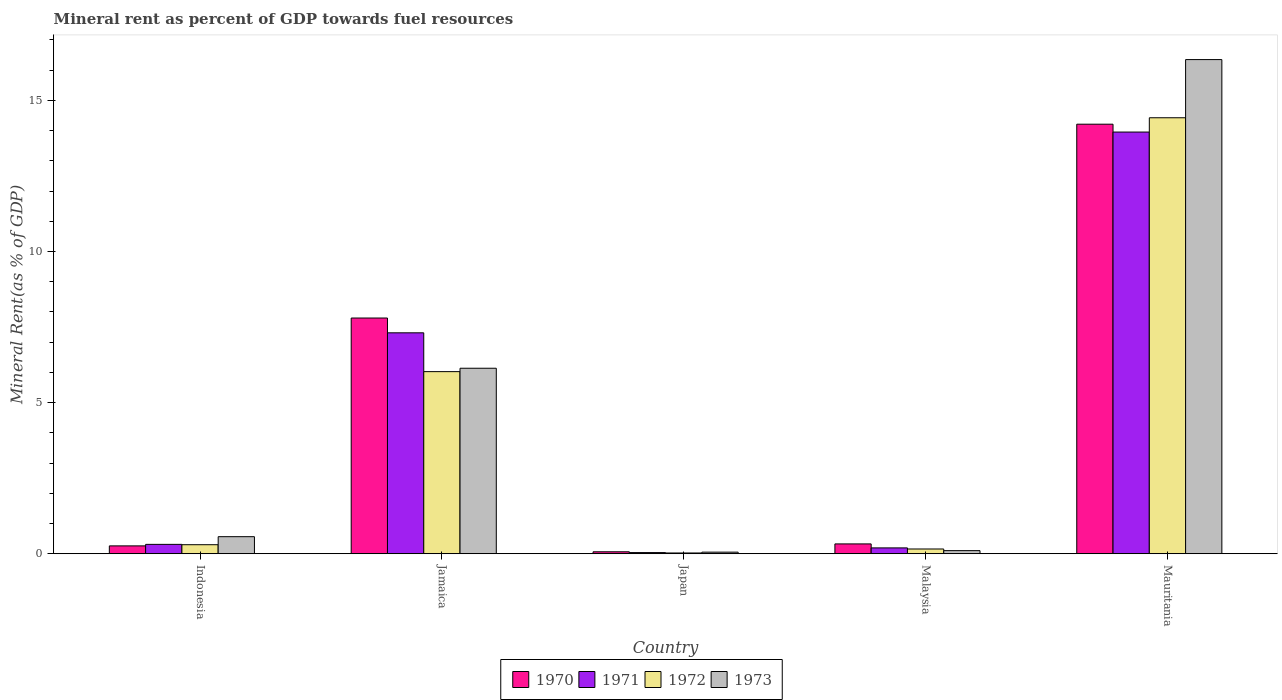How many different coloured bars are there?
Provide a short and direct response. 4. How many groups of bars are there?
Your answer should be compact. 5. Are the number of bars per tick equal to the number of legend labels?
Your answer should be very brief. Yes. Are the number of bars on each tick of the X-axis equal?
Offer a very short reply. Yes. How many bars are there on the 2nd tick from the left?
Give a very brief answer. 4. How many bars are there on the 5th tick from the right?
Your response must be concise. 4. What is the label of the 4th group of bars from the left?
Offer a very short reply. Malaysia. In how many cases, is the number of bars for a given country not equal to the number of legend labels?
Make the answer very short. 0. What is the mineral rent in 1973 in Japan?
Offer a terse response. 0.05. Across all countries, what is the maximum mineral rent in 1973?
Provide a short and direct response. 16.35. Across all countries, what is the minimum mineral rent in 1971?
Keep it short and to the point. 0.04. In which country was the mineral rent in 1972 maximum?
Your answer should be compact. Mauritania. What is the total mineral rent in 1972 in the graph?
Make the answer very short. 20.93. What is the difference between the mineral rent in 1973 in Jamaica and that in Mauritania?
Make the answer very short. -10.21. What is the difference between the mineral rent in 1971 in Japan and the mineral rent in 1970 in Jamaica?
Your answer should be compact. -7.76. What is the average mineral rent in 1970 per country?
Offer a very short reply. 4.53. What is the difference between the mineral rent of/in 1972 and mineral rent of/in 1973 in Jamaica?
Your response must be concise. -0.11. In how many countries, is the mineral rent in 1973 greater than 11 %?
Make the answer very short. 1. What is the ratio of the mineral rent in 1973 in Jamaica to that in Japan?
Keep it short and to the point. 116.18. Is the mineral rent in 1972 in Jamaica less than that in Malaysia?
Keep it short and to the point. No. What is the difference between the highest and the second highest mineral rent in 1973?
Provide a short and direct response. 15.79. What is the difference between the highest and the lowest mineral rent in 1972?
Your response must be concise. 14.4. In how many countries, is the mineral rent in 1971 greater than the average mineral rent in 1971 taken over all countries?
Your response must be concise. 2. Is the sum of the mineral rent in 1973 in Jamaica and Mauritania greater than the maximum mineral rent in 1971 across all countries?
Keep it short and to the point. Yes. What does the 1st bar from the left in Jamaica represents?
Give a very brief answer. 1970. What does the 2nd bar from the right in Malaysia represents?
Your response must be concise. 1972. How many bars are there?
Ensure brevity in your answer.  20. How many countries are there in the graph?
Your response must be concise. 5. Does the graph contain any zero values?
Ensure brevity in your answer.  No. Does the graph contain grids?
Your answer should be compact. No. Where does the legend appear in the graph?
Your answer should be compact. Bottom center. How many legend labels are there?
Offer a terse response. 4. What is the title of the graph?
Your answer should be compact. Mineral rent as percent of GDP towards fuel resources. What is the label or title of the X-axis?
Keep it short and to the point. Country. What is the label or title of the Y-axis?
Offer a very short reply. Mineral Rent(as % of GDP). What is the Mineral Rent(as % of GDP) of 1970 in Indonesia?
Your response must be concise. 0.26. What is the Mineral Rent(as % of GDP) of 1971 in Indonesia?
Provide a short and direct response. 0.31. What is the Mineral Rent(as % of GDP) in 1972 in Indonesia?
Your answer should be compact. 0.3. What is the Mineral Rent(as % of GDP) in 1973 in Indonesia?
Your answer should be compact. 0.56. What is the Mineral Rent(as % of GDP) of 1970 in Jamaica?
Offer a very short reply. 7.8. What is the Mineral Rent(as % of GDP) in 1971 in Jamaica?
Your answer should be very brief. 7.31. What is the Mineral Rent(as % of GDP) of 1972 in Jamaica?
Make the answer very short. 6.03. What is the Mineral Rent(as % of GDP) in 1973 in Jamaica?
Ensure brevity in your answer.  6.14. What is the Mineral Rent(as % of GDP) in 1970 in Japan?
Offer a very short reply. 0.06. What is the Mineral Rent(as % of GDP) in 1971 in Japan?
Give a very brief answer. 0.04. What is the Mineral Rent(as % of GDP) in 1972 in Japan?
Give a very brief answer. 0.03. What is the Mineral Rent(as % of GDP) in 1973 in Japan?
Your response must be concise. 0.05. What is the Mineral Rent(as % of GDP) in 1970 in Malaysia?
Ensure brevity in your answer.  0.33. What is the Mineral Rent(as % of GDP) of 1971 in Malaysia?
Offer a very short reply. 0.19. What is the Mineral Rent(as % of GDP) in 1972 in Malaysia?
Provide a short and direct response. 0.16. What is the Mineral Rent(as % of GDP) in 1973 in Malaysia?
Keep it short and to the point. 0.1. What is the Mineral Rent(as % of GDP) in 1970 in Mauritania?
Make the answer very short. 14.21. What is the Mineral Rent(as % of GDP) of 1971 in Mauritania?
Give a very brief answer. 13.95. What is the Mineral Rent(as % of GDP) in 1972 in Mauritania?
Ensure brevity in your answer.  14.43. What is the Mineral Rent(as % of GDP) in 1973 in Mauritania?
Offer a terse response. 16.35. Across all countries, what is the maximum Mineral Rent(as % of GDP) in 1970?
Provide a succinct answer. 14.21. Across all countries, what is the maximum Mineral Rent(as % of GDP) in 1971?
Your response must be concise. 13.95. Across all countries, what is the maximum Mineral Rent(as % of GDP) in 1972?
Give a very brief answer. 14.43. Across all countries, what is the maximum Mineral Rent(as % of GDP) of 1973?
Your answer should be compact. 16.35. Across all countries, what is the minimum Mineral Rent(as % of GDP) of 1970?
Your answer should be compact. 0.06. Across all countries, what is the minimum Mineral Rent(as % of GDP) in 1971?
Your answer should be very brief. 0.04. Across all countries, what is the minimum Mineral Rent(as % of GDP) of 1972?
Provide a short and direct response. 0.03. Across all countries, what is the minimum Mineral Rent(as % of GDP) of 1973?
Your answer should be very brief. 0.05. What is the total Mineral Rent(as % of GDP) in 1970 in the graph?
Make the answer very short. 22.66. What is the total Mineral Rent(as % of GDP) in 1971 in the graph?
Provide a short and direct response. 21.81. What is the total Mineral Rent(as % of GDP) of 1972 in the graph?
Offer a very short reply. 20.93. What is the total Mineral Rent(as % of GDP) of 1973 in the graph?
Your answer should be very brief. 23.21. What is the difference between the Mineral Rent(as % of GDP) in 1970 in Indonesia and that in Jamaica?
Offer a terse response. -7.54. What is the difference between the Mineral Rent(as % of GDP) in 1971 in Indonesia and that in Jamaica?
Make the answer very short. -7. What is the difference between the Mineral Rent(as % of GDP) in 1972 in Indonesia and that in Jamaica?
Offer a terse response. -5.73. What is the difference between the Mineral Rent(as % of GDP) in 1973 in Indonesia and that in Jamaica?
Provide a short and direct response. -5.57. What is the difference between the Mineral Rent(as % of GDP) in 1970 in Indonesia and that in Japan?
Your answer should be compact. 0.2. What is the difference between the Mineral Rent(as % of GDP) of 1971 in Indonesia and that in Japan?
Provide a short and direct response. 0.27. What is the difference between the Mineral Rent(as % of GDP) in 1972 in Indonesia and that in Japan?
Keep it short and to the point. 0.27. What is the difference between the Mineral Rent(as % of GDP) in 1973 in Indonesia and that in Japan?
Your answer should be very brief. 0.51. What is the difference between the Mineral Rent(as % of GDP) of 1970 in Indonesia and that in Malaysia?
Offer a very short reply. -0.07. What is the difference between the Mineral Rent(as % of GDP) in 1971 in Indonesia and that in Malaysia?
Keep it short and to the point. 0.12. What is the difference between the Mineral Rent(as % of GDP) of 1972 in Indonesia and that in Malaysia?
Your answer should be very brief. 0.14. What is the difference between the Mineral Rent(as % of GDP) of 1973 in Indonesia and that in Malaysia?
Provide a short and direct response. 0.46. What is the difference between the Mineral Rent(as % of GDP) of 1970 in Indonesia and that in Mauritania?
Provide a short and direct response. -13.95. What is the difference between the Mineral Rent(as % of GDP) in 1971 in Indonesia and that in Mauritania?
Offer a terse response. -13.64. What is the difference between the Mineral Rent(as % of GDP) of 1972 in Indonesia and that in Mauritania?
Provide a succinct answer. -14.13. What is the difference between the Mineral Rent(as % of GDP) in 1973 in Indonesia and that in Mauritania?
Make the answer very short. -15.79. What is the difference between the Mineral Rent(as % of GDP) in 1970 in Jamaica and that in Japan?
Give a very brief answer. 7.73. What is the difference between the Mineral Rent(as % of GDP) of 1971 in Jamaica and that in Japan?
Give a very brief answer. 7.27. What is the difference between the Mineral Rent(as % of GDP) in 1972 in Jamaica and that in Japan?
Provide a short and direct response. 6. What is the difference between the Mineral Rent(as % of GDP) of 1973 in Jamaica and that in Japan?
Offer a very short reply. 6.08. What is the difference between the Mineral Rent(as % of GDP) of 1970 in Jamaica and that in Malaysia?
Your response must be concise. 7.47. What is the difference between the Mineral Rent(as % of GDP) in 1971 in Jamaica and that in Malaysia?
Ensure brevity in your answer.  7.12. What is the difference between the Mineral Rent(as % of GDP) of 1972 in Jamaica and that in Malaysia?
Your response must be concise. 5.87. What is the difference between the Mineral Rent(as % of GDP) of 1973 in Jamaica and that in Malaysia?
Your answer should be compact. 6.03. What is the difference between the Mineral Rent(as % of GDP) of 1970 in Jamaica and that in Mauritania?
Ensure brevity in your answer.  -6.41. What is the difference between the Mineral Rent(as % of GDP) of 1971 in Jamaica and that in Mauritania?
Ensure brevity in your answer.  -6.64. What is the difference between the Mineral Rent(as % of GDP) of 1972 in Jamaica and that in Mauritania?
Ensure brevity in your answer.  -8.4. What is the difference between the Mineral Rent(as % of GDP) in 1973 in Jamaica and that in Mauritania?
Give a very brief answer. -10.21. What is the difference between the Mineral Rent(as % of GDP) in 1970 in Japan and that in Malaysia?
Your answer should be compact. -0.26. What is the difference between the Mineral Rent(as % of GDP) of 1971 in Japan and that in Malaysia?
Your response must be concise. -0.16. What is the difference between the Mineral Rent(as % of GDP) in 1972 in Japan and that in Malaysia?
Make the answer very short. -0.13. What is the difference between the Mineral Rent(as % of GDP) of 1973 in Japan and that in Malaysia?
Provide a succinct answer. -0.05. What is the difference between the Mineral Rent(as % of GDP) in 1970 in Japan and that in Mauritania?
Your response must be concise. -14.15. What is the difference between the Mineral Rent(as % of GDP) of 1971 in Japan and that in Mauritania?
Your response must be concise. -13.91. What is the difference between the Mineral Rent(as % of GDP) in 1972 in Japan and that in Mauritania?
Ensure brevity in your answer.  -14.4. What is the difference between the Mineral Rent(as % of GDP) of 1973 in Japan and that in Mauritania?
Provide a short and direct response. -16.3. What is the difference between the Mineral Rent(as % of GDP) of 1970 in Malaysia and that in Mauritania?
Make the answer very short. -13.89. What is the difference between the Mineral Rent(as % of GDP) in 1971 in Malaysia and that in Mauritania?
Offer a terse response. -13.76. What is the difference between the Mineral Rent(as % of GDP) in 1972 in Malaysia and that in Mauritania?
Your response must be concise. -14.27. What is the difference between the Mineral Rent(as % of GDP) in 1973 in Malaysia and that in Mauritania?
Your answer should be very brief. -16.25. What is the difference between the Mineral Rent(as % of GDP) of 1970 in Indonesia and the Mineral Rent(as % of GDP) of 1971 in Jamaica?
Make the answer very short. -7.05. What is the difference between the Mineral Rent(as % of GDP) of 1970 in Indonesia and the Mineral Rent(as % of GDP) of 1972 in Jamaica?
Offer a very short reply. -5.77. What is the difference between the Mineral Rent(as % of GDP) of 1970 in Indonesia and the Mineral Rent(as % of GDP) of 1973 in Jamaica?
Your response must be concise. -5.88. What is the difference between the Mineral Rent(as % of GDP) of 1971 in Indonesia and the Mineral Rent(as % of GDP) of 1972 in Jamaica?
Offer a very short reply. -5.72. What is the difference between the Mineral Rent(as % of GDP) of 1971 in Indonesia and the Mineral Rent(as % of GDP) of 1973 in Jamaica?
Your answer should be compact. -5.83. What is the difference between the Mineral Rent(as % of GDP) in 1972 in Indonesia and the Mineral Rent(as % of GDP) in 1973 in Jamaica?
Make the answer very short. -5.84. What is the difference between the Mineral Rent(as % of GDP) of 1970 in Indonesia and the Mineral Rent(as % of GDP) of 1971 in Japan?
Ensure brevity in your answer.  0.22. What is the difference between the Mineral Rent(as % of GDP) in 1970 in Indonesia and the Mineral Rent(as % of GDP) in 1972 in Japan?
Your answer should be compact. 0.23. What is the difference between the Mineral Rent(as % of GDP) of 1970 in Indonesia and the Mineral Rent(as % of GDP) of 1973 in Japan?
Give a very brief answer. 0.21. What is the difference between the Mineral Rent(as % of GDP) of 1971 in Indonesia and the Mineral Rent(as % of GDP) of 1972 in Japan?
Provide a succinct answer. 0.29. What is the difference between the Mineral Rent(as % of GDP) of 1971 in Indonesia and the Mineral Rent(as % of GDP) of 1973 in Japan?
Make the answer very short. 0.26. What is the difference between the Mineral Rent(as % of GDP) in 1972 in Indonesia and the Mineral Rent(as % of GDP) in 1973 in Japan?
Make the answer very short. 0.25. What is the difference between the Mineral Rent(as % of GDP) of 1970 in Indonesia and the Mineral Rent(as % of GDP) of 1971 in Malaysia?
Your response must be concise. 0.07. What is the difference between the Mineral Rent(as % of GDP) in 1970 in Indonesia and the Mineral Rent(as % of GDP) in 1972 in Malaysia?
Keep it short and to the point. 0.1. What is the difference between the Mineral Rent(as % of GDP) of 1970 in Indonesia and the Mineral Rent(as % of GDP) of 1973 in Malaysia?
Your answer should be very brief. 0.16. What is the difference between the Mineral Rent(as % of GDP) in 1971 in Indonesia and the Mineral Rent(as % of GDP) in 1972 in Malaysia?
Your answer should be compact. 0.15. What is the difference between the Mineral Rent(as % of GDP) of 1971 in Indonesia and the Mineral Rent(as % of GDP) of 1973 in Malaysia?
Offer a terse response. 0.21. What is the difference between the Mineral Rent(as % of GDP) in 1972 in Indonesia and the Mineral Rent(as % of GDP) in 1973 in Malaysia?
Ensure brevity in your answer.  0.2. What is the difference between the Mineral Rent(as % of GDP) in 1970 in Indonesia and the Mineral Rent(as % of GDP) in 1971 in Mauritania?
Your answer should be compact. -13.69. What is the difference between the Mineral Rent(as % of GDP) in 1970 in Indonesia and the Mineral Rent(as % of GDP) in 1972 in Mauritania?
Ensure brevity in your answer.  -14.17. What is the difference between the Mineral Rent(as % of GDP) of 1970 in Indonesia and the Mineral Rent(as % of GDP) of 1973 in Mauritania?
Provide a succinct answer. -16.09. What is the difference between the Mineral Rent(as % of GDP) in 1971 in Indonesia and the Mineral Rent(as % of GDP) in 1972 in Mauritania?
Your answer should be very brief. -14.12. What is the difference between the Mineral Rent(as % of GDP) of 1971 in Indonesia and the Mineral Rent(as % of GDP) of 1973 in Mauritania?
Your answer should be very brief. -16.04. What is the difference between the Mineral Rent(as % of GDP) in 1972 in Indonesia and the Mineral Rent(as % of GDP) in 1973 in Mauritania?
Offer a terse response. -16.05. What is the difference between the Mineral Rent(as % of GDP) of 1970 in Jamaica and the Mineral Rent(as % of GDP) of 1971 in Japan?
Make the answer very short. 7.76. What is the difference between the Mineral Rent(as % of GDP) in 1970 in Jamaica and the Mineral Rent(as % of GDP) in 1972 in Japan?
Make the answer very short. 7.77. What is the difference between the Mineral Rent(as % of GDP) of 1970 in Jamaica and the Mineral Rent(as % of GDP) of 1973 in Japan?
Keep it short and to the point. 7.75. What is the difference between the Mineral Rent(as % of GDP) of 1971 in Jamaica and the Mineral Rent(as % of GDP) of 1972 in Japan?
Your answer should be compact. 7.28. What is the difference between the Mineral Rent(as % of GDP) of 1971 in Jamaica and the Mineral Rent(as % of GDP) of 1973 in Japan?
Give a very brief answer. 7.26. What is the difference between the Mineral Rent(as % of GDP) of 1972 in Jamaica and the Mineral Rent(as % of GDP) of 1973 in Japan?
Make the answer very short. 5.97. What is the difference between the Mineral Rent(as % of GDP) in 1970 in Jamaica and the Mineral Rent(as % of GDP) in 1971 in Malaysia?
Your answer should be very brief. 7.61. What is the difference between the Mineral Rent(as % of GDP) of 1970 in Jamaica and the Mineral Rent(as % of GDP) of 1972 in Malaysia?
Give a very brief answer. 7.64. What is the difference between the Mineral Rent(as % of GDP) in 1970 in Jamaica and the Mineral Rent(as % of GDP) in 1973 in Malaysia?
Your answer should be compact. 7.7. What is the difference between the Mineral Rent(as % of GDP) of 1971 in Jamaica and the Mineral Rent(as % of GDP) of 1972 in Malaysia?
Offer a very short reply. 7.15. What is the difference between the Mineral Rent(as % of GDP) of 1971 in Jamaica and the Mineral Rent(as % of GDP) of 1973 in Malaysia?
Provide a short and direct response. 7.21. What is the difference between the Mineral Rent(as % of GDP) of 1972 in Jamaica and the Mineral Rent(as % of GDP) of 1973 in Malaysia?
Offer a very short reply. 5.92. What is the difference between the Mineral Rent(as % of GDP) in 1970 in Jamaica and the Mineral Rent(as % of GDP) in 1971 in Mauritania?
Your response must be concise. -6.15. What is the difference between the Mineral Rent(as % of GDP) in 1970 in Jamaica and the Mineral Rent(as % of GDP) in 1972 in Mauritania?
Provide a short and direct response. -6.63. What is the difference between the Mineral Rent(as % of GDP) in 1970 in Jamaica and the Mineral Rent(as % of GDP) in 1973 in Mauritania?
Provide a short and direct response. -8.55. What is the difference between the Mineral Rent(as % of GDP) in 1971 in Jamaica and the Mineral Rent(as % of GDP) in 1972 in Mauritania?
Keep it short and to the point. -7.12. What is the difference between the Mineral Rent(as % of GDP) in 1971 in Jamaica and the Mineral Rent(as % of GDP) in 1973 in Mauritania?
Your answer should be compact. -9.04. What is the difference between the Mineral Rent(as % of GDP) of 1972 in Jamaica and the Mineral Rent(as % of GDP) of 1973 in Mauritania?
Give a very brief answer. -10.32. What is the difference between the Mineral Rent(as % of GDP) in 1970 in Japan and the Mineral Rent(as % of GDP) in 1971 in Malaysia?
Give a very brief answer. -0.13. What is the difference between the Mineral Rent(as % of GDP) of 1970 in Japan and the Mineral Rent(as % of GDP) of 1972 in Malaysia?
Your answer should be compact. -0.09. What is the difference between the Mineral Rent(as % of GDP) of 1970 in Japan and the Mineral Rent(as % of GDP) of 1973 in Malaysia?
Give a very brief answer. -0.04. What is the difference between the Mineral Rent(as % of GDP) in 1971 in Japan and the Mineral Rent(as % of GDP) in 1972 in Malaysia?
Ensure brevity in your answer.  -0.12. What is the difference between the Mineral Rent(as % of GDP) in 1971 in Japan and the Mineral Rent(as % of GDP) in 1973 in Malaysia?
Your answer should be compact. -0.06. What is the difference between the Mineral Rent(as % of GDP) in 1972 in Japan and the Mineral Rent(as % of GDP) in 1973 in Malaysia?
Give a very brief answer. -0.08. What is the difference between the Mineral Rent(as % of GDP) of 1970 in Japan and the Mineral Rent(as % of GDP) of 1971 in Mauritania?
Offer a very short reply. -13.89. What is the difference between the Mineral Rent(as % of GDP) of 1970 in Japan and the Mineral Rent(as % of GDP) of 1972 in Mauritania?
Provide a succinct answer. -14.36. What is the difference between the Mineral Rent(as % of GDP) of 1970 in Japan and the Mineral Rent(as % of GDP) of 1973 in Mauritania?
Make the answer very short. -16.29. What is the difference between the Mineral Rent(as % of GDP) of 1971 in Japan and the Mineral Rent(as % of GDP) of 1972 in Mauritania?
Give a very brief answer. -14.39. What is the difference between the Mineral Rent(as % of GDP) of 1971 in Japan and the Mineral Rent(as % of GDP) of 1973 in Mauritania?
Give a very brief answer. -16.31. What is the difference between the Mineral Rent(as % of GDP) in 1972 in Japan and the Mineral Rent(as % of GDP) in 1973 in Mauritania?
Give a very brief answer. -16.33. What is the difference between the Mineral Rent(as % of GDP) in 1970 in Malaysia and the Mineral Rent(as % of GDP) in 1971 in Mauritania?
Your response must be concise. -13.63. What is the difference between the Mineral Rent(as % of GDP) of 1970 in Malaysia and the Mineral Rent(as % of GDP) of 1972 in Mauritania?
Ensure brevity in your answer.  -14.1. What is the difference between the Mineral Rent(as % of GDP) of 1970 in Malaysia and the Mineral Rent(as % of GDP) of 1973 in Mauritania?
Ensure brevity in your answer.  -16.03. What is the difference between the Mineral Rent(as % of GDP) of 1971 in Malaysia and the Mineral Rent(as % of GDP) of 1972 in Mauritania?
Provide a short and direct response. -14.23. What is the difference between the Mineral Rent(as % of GDP) in 1971 in Malaysia and the Mineral Rent(as % of GDP) in 1973 in Mauritania?
Provide a succinct answer. -16.16. What is the difference between the Mineral Rent(as % of GDP) in 1972 in Malaysia and the Mineral Rent(as % of GDP) in 1973 in Mauritania?
Provide a short and direct response. -16.19. What is the average Mineral Rent(as % of GDP) in 1970 per country?
Your answer should be compact. 4.53. What is the average Mineral Rent(as % of GDP) in 1971 per country?
Give a very brief answer. 4.36. What is the average Mineral Rent(as % of GDP) in 1972 per country?
Your response must be concise. 4.19. What is the average Mineral Rent(as % of GDP) in 1973 per country?
Offer a terse response. 4.64. What is the difference between the Mineral Rent(as % of GDP) in 1970 and Mineral Rent(as % of GDP) in 1971 in Indonesia?
Make the answer very short. -0.05. What is the difference between the Mineral Rent(as % of GDP) in 1970 and Mineral Rent(as % of GDP) in 1972 in Indonesia?
Give a very brief answer. -0.04. What is the difference between the Mineral Rent(as % of GDP) of 1970 and Mineral Rent(as % of GDP) of 1973 in Indonesia?
Offer a very short reply. -0.3. What is the difference between the Mineral Rent(as % of GDP) of 1971 and Mineral Rent(as % of GDP) of 1972 in Indonesia?
Ensure brevity in your answer.  0.01. What is the difference between the Mineral Rent(as % of GDP) of 1971 and Mineral Rent(as % of GDP) of 1973 in Indonesia?
Keep it short and to the point. -0.25. What is the difference between the Mineral Rent(as % of GDP) of 1972 and Mineral Rent(as % of GDP) of 1973 in Indonesia?
Your answer should be compact. -0.27. What is the difference between the Mineral Rent(as % of GDP) in 1970 and Mineral Rent(as % of GDP) in 1971 in Jamaica?
Your answer should be very brief. 0.49. What is the difference between the Mineral Rent(as % of GDP) in 1970 and Mineral Rent(as % of GDP) in 1972 in Jamaica?
Ensure brevity in your answer.  1.77. What is the difference between the Mineral Rent(as % of GDP) in 1970 and Mineral Rent(as % of GDP) in 1973 in Jamaica?
Make the answer very short. 1.66. What is the difference between the Mineral Rent(as % of GDP) of 1971 and Mineral Rent(as % of GDP) of 1972 in Jamaica?
Provide a succinct answer. 1.28. What is the difference between the Mineral Rent(as % of GDP) in 1971 and Mineral Rent(as % of GDP) in 1973 in Jamaica?
Provide a short and direct response. 1.17. What is the difference between the Mineral Rent(as % of GDP) of 1972 and Mineral Rent(as % of GDP) of 1973 in Jamaica?
Your answer should be compact. -0.11. What is the difference between the Mineral Rent(as % of GDP) in 1970 and Mineral Rent(as % of GDP) in 1971 in Japan?
Offer a terse response. 0.03. What is the difference between the Mineral Rent(as % of GDP) of 1970 and Mineral Rent(as % of GDP) of 1972 in Japan?
Offer a terse response. 0.04. What is the difference between the Mineral Rent(as % of GDP) in 1970 and Mineral Rent(as % of GDP) in 1973 in Japan?
Offer a very short reply. 0.01. What is the difference between the Mineral Rent(as % of GDP) of 1971 and Mineral Rent(as % of GDP) of 1972 in Japan?
Give a very brief answer. 0.01. What is the difference between the Mineral Rent(as % of GDP) of 1971 and Mineral Rent(as % of GDP) of 1973 in Japan?
Offer a very short reply. -0.01. What is the difference between the Mineral Rent(as % of GDP) in 1972 and Mineral Rent(as % of GDP) in 1973 in Japan?
Keep it short and to the point. -0.03. What is the difference between the Mineral Rent(as % of GDP) of 1970 and Mineral Rent(as % of GDP) of 1971 in Malaysia?
Offer a terse response. 0.13. What is the difference between the Mineral Rent(as % of GDP) in 1970 and Mineral Rent(as % of GDP) in 1972 in Malaysia?
Ensure brevity in your answer.  0.17. What is the difference between the Mineral Rent(as % of GDP) of 1970 and Mineral Rent(as % of GDP) of 1973 in Malaysia?
Make the answer very short. 0.22. What is the difference between the Mineral Rent(as % of GDP) of 1971 and Mineral Rent(as % of GDP) of 1972 in Malaysia?
Your response must be concise. 0.04. What is the difference between the Mineral Rent(as % of GDP) of 1971 and Mineral Rent(as % of GDP) of 1973 in Malaysia?
Your answer should be very brief. 0.09. What is the difference between the Mineral Rent(as % of GDP) of 1972 and Mineral Rent(as % of GDP) of 1973 in Malaysia?
Your answer should be compact. 0.05. What is the difference between the Mineral Rent(as % of GDP) of 1970 and Mineral Rent(as % of GDP) of 1971 in Mauritania?
Offer a very short reply. 0.26. What is the difference between the Mineral Rent(as % of GDP) in 1970 and Mineral Rent(as % of GDP) in 1972 in Mauritania?
Provide a succinct answer. -0.21. What is the difference between the Mineral Rent(as % of GDP) in 1970 and Mineral Rent(as % of GDP) in 1973 in Mauritania?
Make the answer very short. -2.14. What is the difference between the Mineral Rent(as % of GDP) in 1971 and Mineral Rent(as % of GDP) in 1972 in Mauritania?
Your response must be concise. -0.47. What is the difference between the Mineral Rent(as % of GDP) of 1971 and Mineral Rent(as % of GDP) of 1973 in Mauritania?
Ensure brevity in your answer.  -2.4. What is the difference between the Mineral Rent(as % of GDP) in 1972 and Mineral Rent(as % of GDP) in 1973 in Mauritania?
Give a very brief answer. -1.93. What is the ratio of the Mineral Rent(as % of GDP) in 1971 in Indonesia to that in Jamaica?
Ensure brevity in your answer.  0.04. What is the ratio of the Mineral Rent(as % of GDP) of 1972 in Indonesia to that in Jamaica?
Your response must be concise. 0.05. What is the ratio of the Mineral Rent(as % of GDP) of 1973 in Indonesia to that in Jamaica?
Give a very brief answer. 0.09. What is the ratio of the Mineral Rent(as % of GDP) in 1970 in Indonesia to that in Japan?
Your response must be concise. 4.01. What is the ratio of the Mineral Rent(as % of GDP) in 1971 in Indonesia to that in Japan?
Provide a short and direct response. 8.06. What is the ratio of the Mineral Rent(as % of GDP) in 1972 in Indonesia to that in Japan?
Give a very brief answer. 11.82. What is the ratio of the Mineral Rent(as % of GDP) of 1973 in Indonesia to that in Japan?
Your answer should be very brief. 10.69. What is the ratio of the Mineral Rent(as % of GDP) of 1970 in Indonesia to that in Malaysia?
Give a very brief answer. 0.8. What is the ratio of the Mineral Rent(as % of GDP) in 1971 in Indonesia to that in Malaysia?
Your answer should be compact. 1.6. What is the ratio of the Mineral Rent(as % of GDP) of 1972 in Indonesia to that in Malaysia?
Your answer should be compact. 1.9. What is the ratio of the Mineral Rent(as % of GDP) of 1973 in Indonesia to that in Malaysia?
Your response must be concise. 5.47. What is the ratio of the Mineral Rent(as % of GDP) in 1970 in Indonesia to that in Mauritania?
Keep it short and to the point. 0.02. What is the ratio of the Mineral Rent(as % of GDP) of 1971 in Indonesia to that in Mauritania?
Provide a succinct answer. 0.02. What is the ratio of the Mineral Rent(as % of GDP) of 1972 in Indonesia to that in Mauritania?
Your answer should be very brief. 0.02. What is the ratio of the Mineral Rent(as % of GDP) in 1973 in Indonesia to that in Mauritania?
Provide a short and direct response. 0.03. What is the ratio of the Mineral Rent(as % of GDP) in 1970 in Jamaica to that in Japan?
Offer a terse response. 120.23. What is the ratio of the Mineral Rent(as % of GDP) in 1971 in Jamaica to that in Japan?
Your response must be concise. 189.73. What is the ratio of the Mineral Rent(as % of GDP) of 1972 in Jamaica to that in Japan?
Provide a short and direct response. 238.51. What is the ratio of the Mineral Rent(as % of GDP) in 1973 in Jamaica to that in Japan?
Your answer should be very brief. 116.18. What is the ratio of the Mineral Rent(as % of GDP) in 1970 in Jamaica to that in Malaysia?
Provide a succinct answer. 23.97. What is the ratio of the Mineral Rent(as % of GDP) in 1971 in Jamaica to that in Malaysia?
Provide a succinct answer. 37.76. What is the ratio of the Mineral Rent(as % of GDP) in 1972 in Jamaica to that in Malaysia?
Give a very brief answer. 38.36. What is the ratio of the Mineral Rent(as % of GDP) of 1973 in Jamaica to that in Malaysia?
Your answer should be very brief. 59.49. What is the ratio of the Mineral Rent(as % of GDP) of 1970 in Jamaica to that in Mauritania?
Provide a short and direct response. 0.55. What is the ratio of the Mineral Rent(as % of GDP) of 1971 in Jamaica to that in Mauritania?
Ensure brevity in your answer.  0.52. What is the ratio of the Mineral Rent(as % of GDP) in 1972 in Jamaica to that in Mauritania?
Offer a terse response. 0.42. What is the ratio of the Mineral Rent(as % of GDP) of 1973 in Jamaica to that in Mauritania?
Your answer should be compact. 0.38. What is the ratio of the Mineral Rent(as % of GDP) of 1970 in Japan to that in Malaysia?
Give a very brief answer. 0.2. What is the ratio of the Mineral Rent(as % of GDP) in 1971 in Japan to that in Malaysia?
Provide a short and direct response. 0.2. What is the ratio of the Mineral Rent(as % of GDP) in 1972 in Japan to that in Malaysia?
Ensure brevity in your answer.  0.16. What is the ratio of the Mineral Rent(as % of GDP) of 1973 in Japan to that in Malaysia?
Keep it short and to the point. 0.51. What is the ratio of the Mineral Rent(as % of GDP) in 1970 in Japan to that in Mauritania?
Offer a very short reply. 0. What is the ratio of the Mineral Rent(as % of GDP) in 1971 in Japan to that in Mauritania?
Your answer should be very brief. 0. What is the ratio of the Mineral Rent(as % of GDP) of 1972 in Japan to that in Mauritania?
Offer a terse response. 0. What is the ratio of the Mineral Rent(as % of GDP) in 1973 in Japan to that in Mauritania?
Give a very brief answer. 0. What is the ratio of the Mineral Rent(as % of GDP) in 1970 in Malaysia to that in Mauritania?
Make the answer very short. 0.02. What is the ratio of the Mineral Rent(as % of GDP) in 1971 in Malaysia to that in Mauritania?
Keep it short and to the point. 0.01. What is the ratio of the Mineral Rent(as % of GDP) in 1972 in Malaysia to that in Mauritania?
Ensure brevity in your answer.  0.01. What is the ratio of the Mineral Rent(as % of GDP) in 1973 in Malaysia to that in Mauritania?
Make the answer very short. 0.01. What is the difference between the highest and the second highest Mineral Rent(as % of GDP) in 1970?
Offer a very short reply. 6.41. What is the difference between the highest and the second highest Mineral Rent(as % of GDP) of 1971?
Keep it short and to the point. 6.64. What is the difference between the highest and the second highest Mineral Rent(as % of GDP) of 1973?
Keep it short and to the point. 10.21. What is the difference between the highest and the lowest Mineral Rent(as % of GDP) of 1970?
Offer a very short reply. 14.15. What is the difference between the highest and the lowest Mineral Rent(as % of GDP) in 1971?
Make the answer very short. 13.91. What is the difference between the highest and the lowest Mineral Rent(as % of GDP) in 1972?
Your answer should be very brief. 14.4. What is the difference between the highest and the lowest Mineral Rent(as % of GDP) in 1973?
Ensure brevity in your answer.  16.3. 